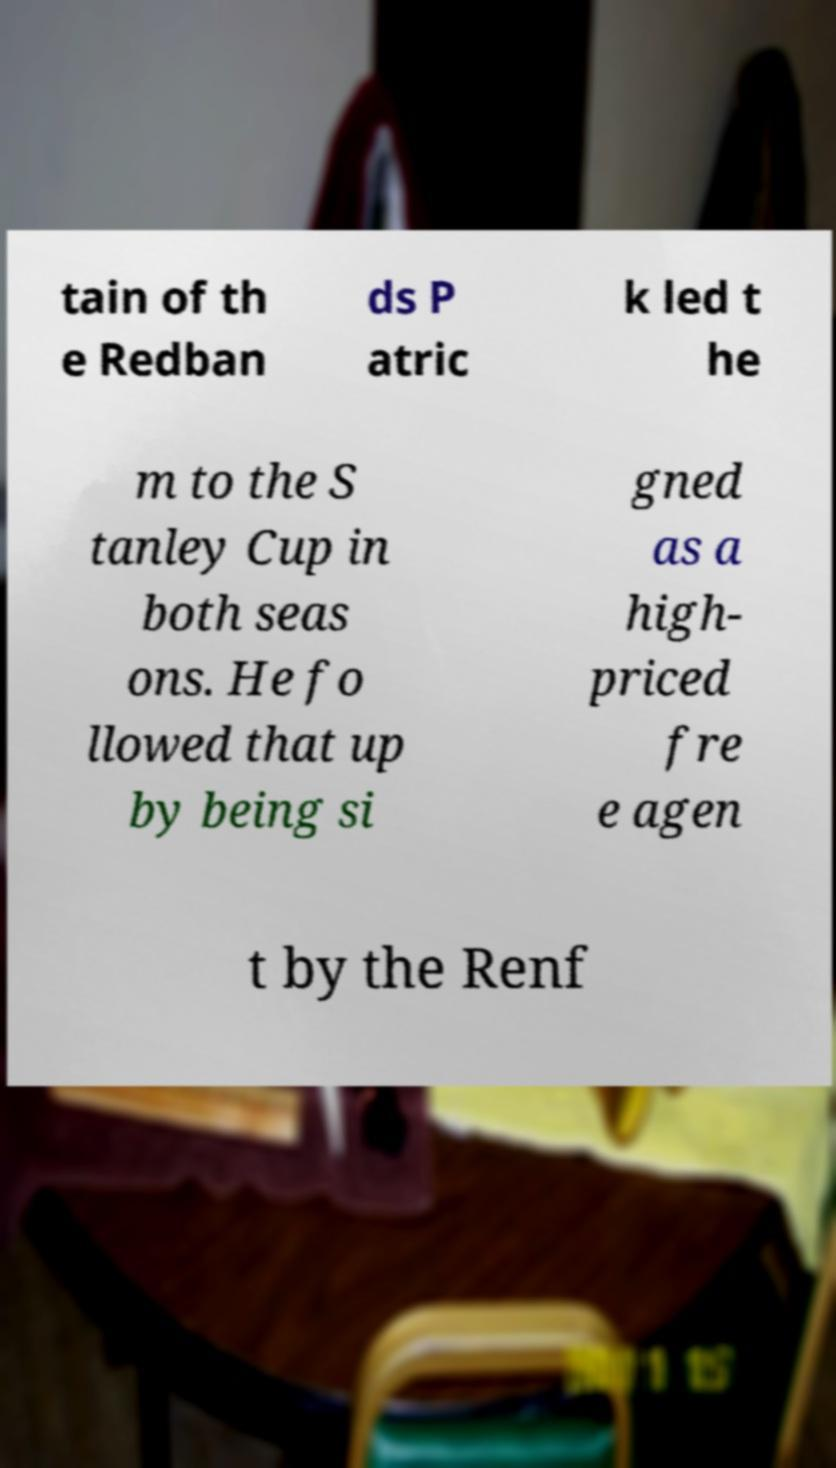Please identify and transcribe the text found in this image. tain of th e Redban ds P atric k led t he m to the S tanley Cup in both seas ons. He fo llowed that up by being si gned as a high- priced fre e agen t by the Renf 